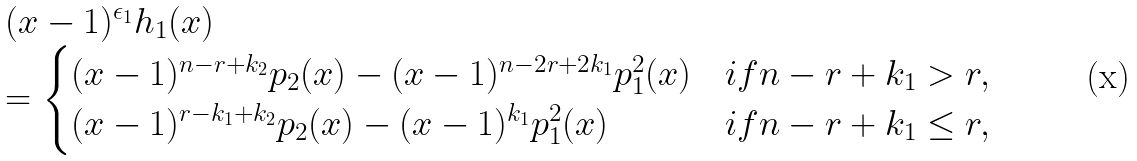<formula> <loc_0><loc_0><loc_500><loc_500>\begin{array} { l } ( x - 1 ) ^ { \epsilon _ { 1 } } h _ { 1 } ( x ) \\ = \begin{cases} ( x - 1 ) ^ { n - r + k _ { 2 } } p _ { 2 } ( x ) - ( x - 1 ) ^ { n - 2 r + 2 k _ { 1 } } p _ { 1 } ^ { 2 } ( x ) & i f n - r + k _ { 1 } > r , \\ ( x - 1 ) ^ { r - k _ { 1 } + k _ { 2 } } p _ { 2 } ( x ) - ( x - 1 ) ^ { k _ { 1 } } p _ { 1 } ^ { 2 } ( x ) & i f n - r + k _ { 1 } \leq r , \end{cases} \end{array}</formula> 